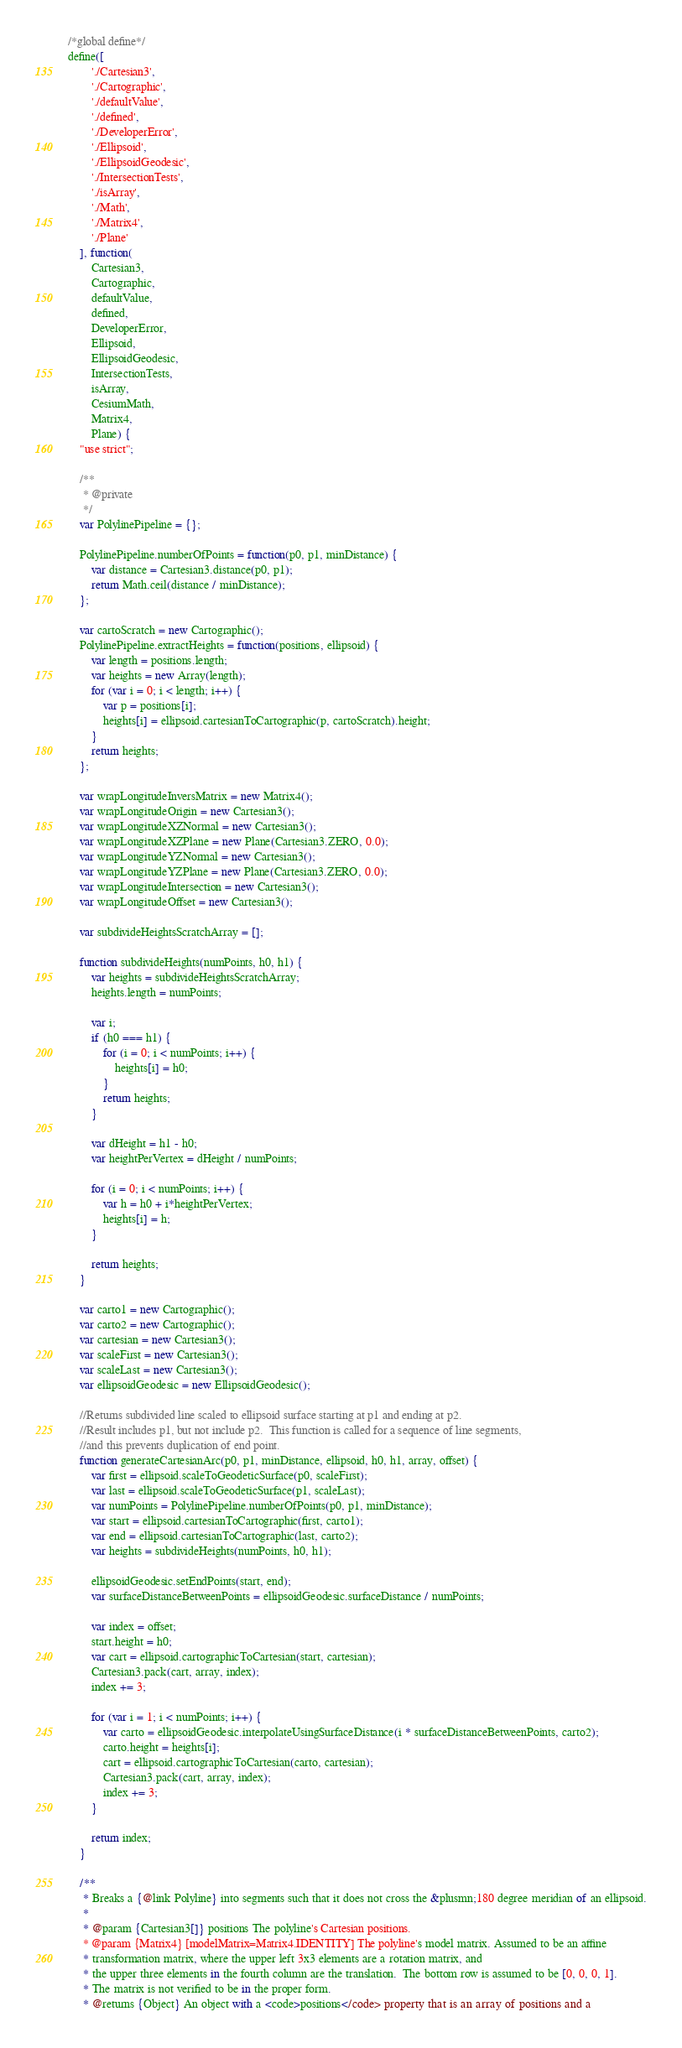Convert code to text. <code><loc_0><loc_0><loc_500><loc_500><_JavaScript_>/*global define*/
define([
        './Cartesian3',
        './Cartographic',
        './defaultValue',
        './defined',
        './DeveloperError',
        './Ellipsoid',
        './EllipsoidGeodesic',
        './IntersectionTests',
        './isArray',
        './Math',
        './Matrix4',
        './Plane'
    ], function(
        Cartesian3,
        Cartographic,
        defaultValue,
        defined,
        DeveloperError,
        Ellipsoid,
        EllipsoidGeodesic,
        IntersectionTests,
        isArray,
        CesiumMath,
        Matrix4,
        Plane) {
    "use strict";

    /**
     * @private
     */
    var PolylinePipeline = {};

    PolylinePipeline.numberOfPoints = function(p0, p1, minDistance) {
        var distance = Cartesian3.distance(p0, p1);
        return Math.ceil(distance / minDistance);
    };

    var cartoScratch = new Cartographic();
    PolylinePipeline.extractHeights = function(positions, ellipsoid) {
        var length = positions.length;
        var heights = new Array(length);
        for (var i = 0; i < length; i++) {
            var p = positions[i];
            heights[i] = ellipsoid.cartesianToCartographic(p, cartoScratch).height;
        }
        return heights;
    };

    var wrapLongitudeInversMatrix = new Matrix4();
    var wrapLongitudeOrigin = new Cartesian3();
    var wrapLongitudeXZNormal = new Cartesian3();
    var wrapLongitudeXZPlane = new Plane(Cartesian3.ZERO, 0.0);
    var wrapLongitudeYZNormal = new Cartesian3();
    var wrapLongitudeYZPlane = new Plane(Cartesian3.ZERO, 0.0);
    var wrapLongitudeIntersection = new Cartesian3();
    var wrapLongitudeOffset = new Cartesian3();

    var subdivideHeightsScratchArray = [];

    function subdivideHeights(numPoints, h0, h1) {
        var heights = subdivideHeightsScratchArray;
        heights.length = numPoints;

        var i;
        if (h0 === h1) {
            for (i = 0; i < numPoints; i++) {
                heights[i] = h0;
            }
            return heights;
        }

        var dHeight = h1 - h0;
        var heightPerVertex = dHeight / numPoints;

        for (i = 0; i < numPoints; i++) {
            var h = h0 + i*heightPerVertex;
            heights[i] = h;
        }

        return heights;
    }

    var carto1 = new Cartographic();
    var carto2 = new Cartographic();
    var cartesian = new Cartesian3();
    var scaleFirst = new Cartesian3();
    var scaleLast = new Cartesian3();
    var ellipsoidGeodesic = new EllipsoidGeodesic();

    //Returns subdivided line scaled to ellipsoid surface starting at p1 and ending at p2.
    //Result includes p1, but not include p2.  This function is called for a sequence of line segments,
    //and this prevents duplication of end point.
    function generateCartesianArc(p0, p1, minDistance, ellipsoid, h0, h1, array, offset) {
        var first = ellipsoid.scaleToGeodeticSurface(p0, scaleFirst);
        var last = ellipsoid.scaleToGeodeticSurface(p1, scaleLast);
        var numPoints = PolylinePipeline.numberOfPoints(p0, p1, minDistance);
        var start = ellipsoid.cartesianToCartographic(first, carto1);
        var end = ellipsoid.cartesianToCartographic(last, carto2);
        var heights = subdivideHeights(numPoints, h0, h1);

        ellipsoidGeodesic.setEndPoints(start, end);
        var surfaceDistanceBetweenPoints = ellipsoidGeodesic.surfaceDistance / numPoints;

        var index = offset;
        start.height = h0;
        var cart = ellipsoid.cartographicToCartesian(start, cartesian);
        Cartesian3.pack(cart, array, index);
        index += 3;

        for (var i = 1; i < numPoints; i++) {
            var carto = ellipsoidGeodesic.interpolateUsingSurfaceDistance(i * surfaceDistanceBetweenPoints, carto2);
            carto.height = heights[i];
            cart = ellipsoid.cartographicToCartesian(carto, cartesian);
            Cartesian3.pack(cart, array, index);
            index += 3;
        }

        return index;
    }

    /**
     * Breaks a {@link Polyline} into segments such that it does not cross the &plusmn;180 degree meridian of an ellipsoid.
     *
     * @param {Cartesian3[]} positions The polyline's Cartesian positions.
     * @param {Matrix4} [modelMatrix=Matrix4.IDENTITY] The polyline's model matrix. Assumed to be an affine
     * transformation matrix, where the upper left 3x3 elements are a rotation matrix, and
     * the upper three elements in the fourth column are the translation.  The bottom row is assumed to be [0, 0, 0, 1].
     * The matrix is not verified to be in the proper form.
     * @returns {Object} An object with a <code>positions</code> property that is an array of positions and a</code> 